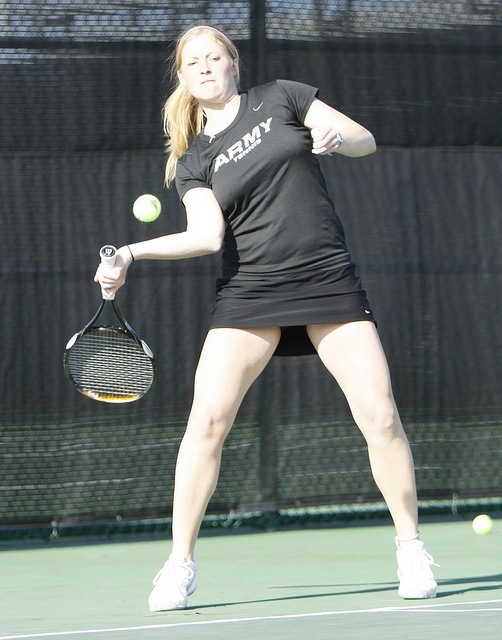Describe the objects in this image and their specific colors. I can see people in darkgray, ivory, gray, and black tones, tennis racket in darkgray, gray, black, and lightgray tones, sports ball in darkgray, gray, and ivory tones, and sports ball in darkgray, ivory, khaki, darkgreen, and lightgreen tones in this image. 